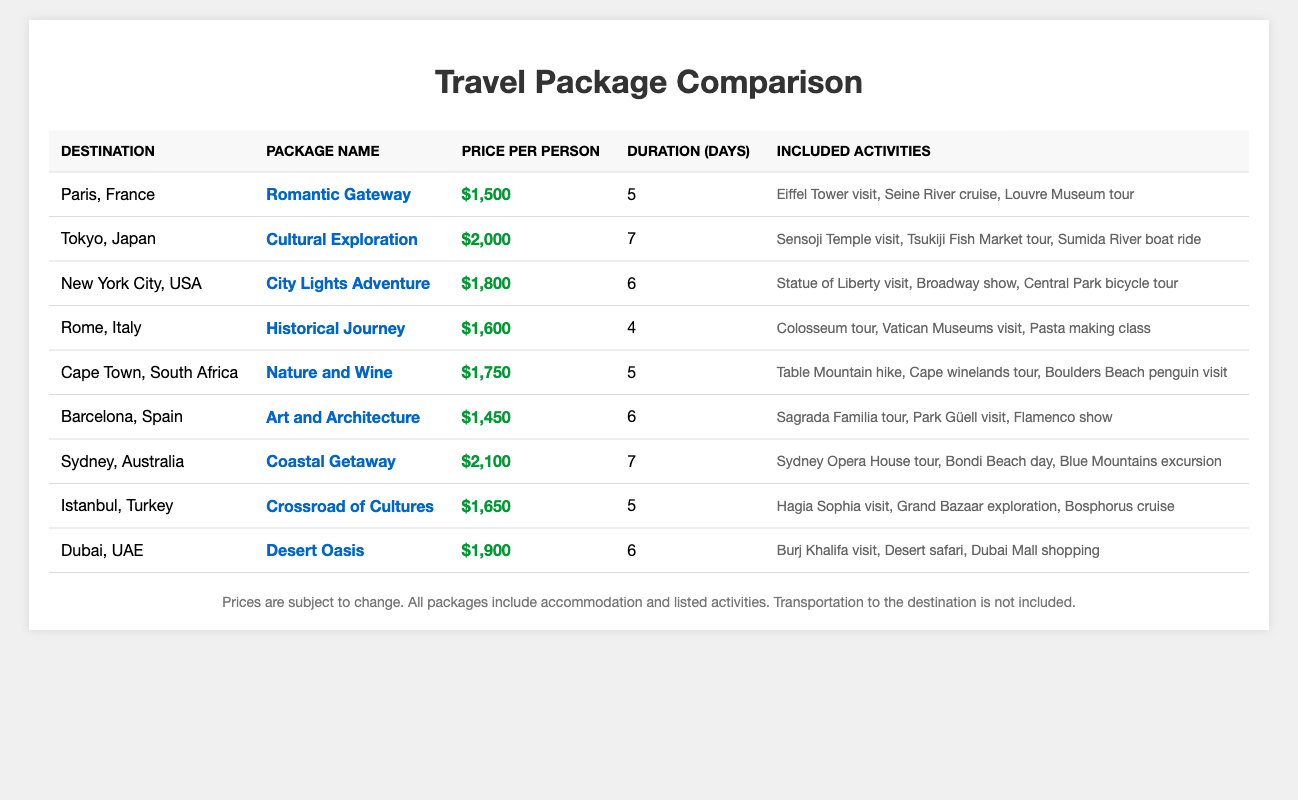What is the cheapest travel package listed? The table shows various travel packages with their prices. By scanning through the "Price per Person" column, I find that the lowest price is $1,450 for the "Art and Architecture" package in Barcelona, Spain.
Answer: $1,450 How many days does the "Cultural Exploration" package in Tokyo last? In the table, I locate the row for the "Cultural Exploration" package, which is clearly marked under the destination Tokyo, Japan. The duration listed for this package is 7 days.
Answer: 7 days What activities are included in the "Nature and Wine" package? By looking at the row for "Nature and Wine" under Cape Town, South Africa, I can see the "Included Activities" column lists "Table Mountain hike, Cape winelands tour, Boulders Beach penguin visit."
Answer: Table Mountain hike, Cape winelands tour, Boulders Beach penguin visit What is the average price of the travel packages? I will add all the prices from the "Price per Person" column: ($1,500 + $2,000 + $1,800 + $1,600 + $1,750 + $1,450 + $2,100 + $1,650 + $1,900) = $15,850. There are 9 packages, so the average price is $15,850/9, which is approximately $1,761.
Answer: $1,761 Is the "Romantic Gateway" package in Paris more expensive than the "Historical Journey" package in Rome? The "Romantic Gateway" package is priced at $1,500, while the "Historical Journey" package is priced at $1,600. Since $1,500 is less than $1,600, the statement is false.
Answer: No Which package has the longest duration and what is its price? Looking at the duration of each package, I see that the "Cultural Exploration" and "Coastal Getaway" packages last 7 days each. Their prices are $2,000 and $2,100 respectively. The longest duration is 7 days, and the higher price is $2,100.
Answer: 7 days, $2,100 How much more expensive is the "Desert Oasis" package compared to the "Art and Architecture" package? The "Desert Oasis" is priced at $1,900, and the "Art and Architecture" package is $1,450. The difference is $1,900 - $1,450 = $450.
Answer: $450 If a client wants a package that includes a visit to the Eiffel Tower and a river cruise, which option should they choose? The "Romantic Gateway" package in Paris includes both the "Eiffel Tower visit" and "Seine River cruise." Thus, this would be the suitable option for the client.
Answer: Romantic Gateway How many packages include activities related to nature? I will count the packages that include nature-related activities. The "Nature and Wine" package includes "Table Mountain hike," and the "Coastal Getaway" includes "Bondi Beach day" and "Blue Mountains excursion." Thus, there are 2 packages that include nature-related activities.
Answer: 2 packages If a client has $2,000 to spend, which packages are within that budget? I will check the prices of all packages against the $2,000 budget. The packages within this price are "Romantic Gateway," "Historical Journey," "Nature and Wine," "Art and Architecture," and "Desert Oasis." Their prices are $1,500, $1,600, $1,750, $1,450, and $1,900, respectively. In total, there are 5 packages that fit the client's budget.
Answer: 5 packages 